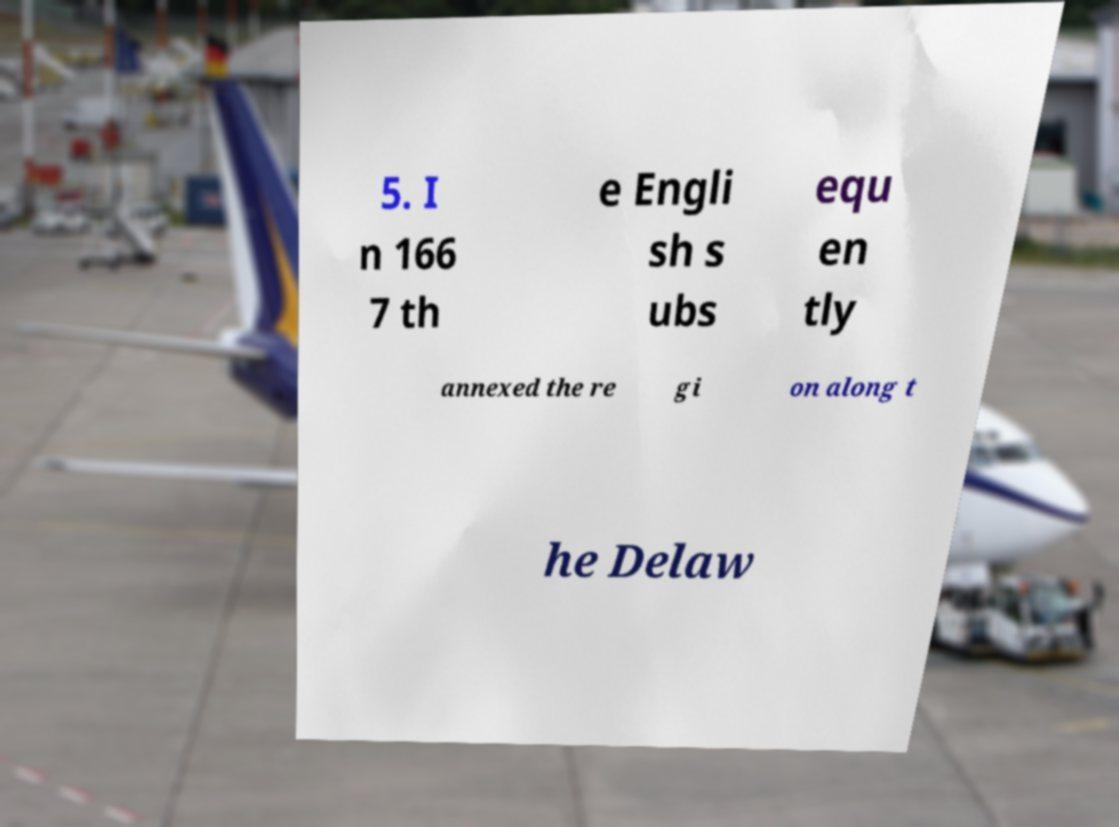For documentation purposes, I need the text within this image transcribed. Could you provide that? 5. I n 166 7 th e Engli sh s ubs equ en tly annexed the re gi on along t he Delaw 